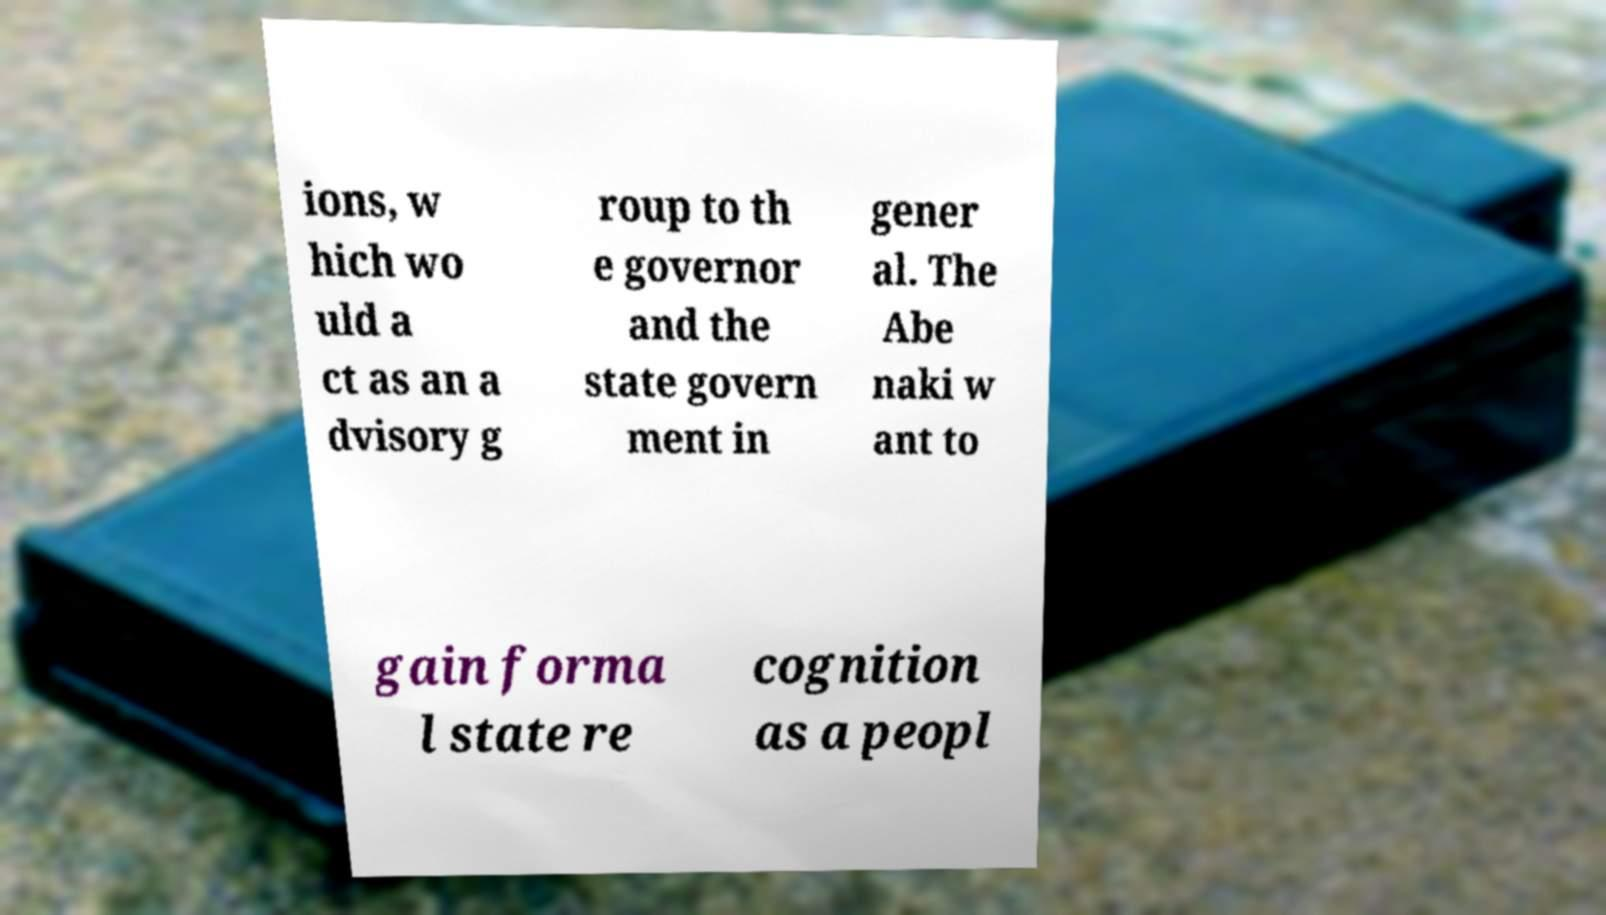Can you accurately transcribe the text from the provided image for me? ions, w hich wo uld a ct as an a dvisory g roup to th e governor and the state govern ment in gener al. The Abe naki w ant to gain forma l state re cognition as a peopl 